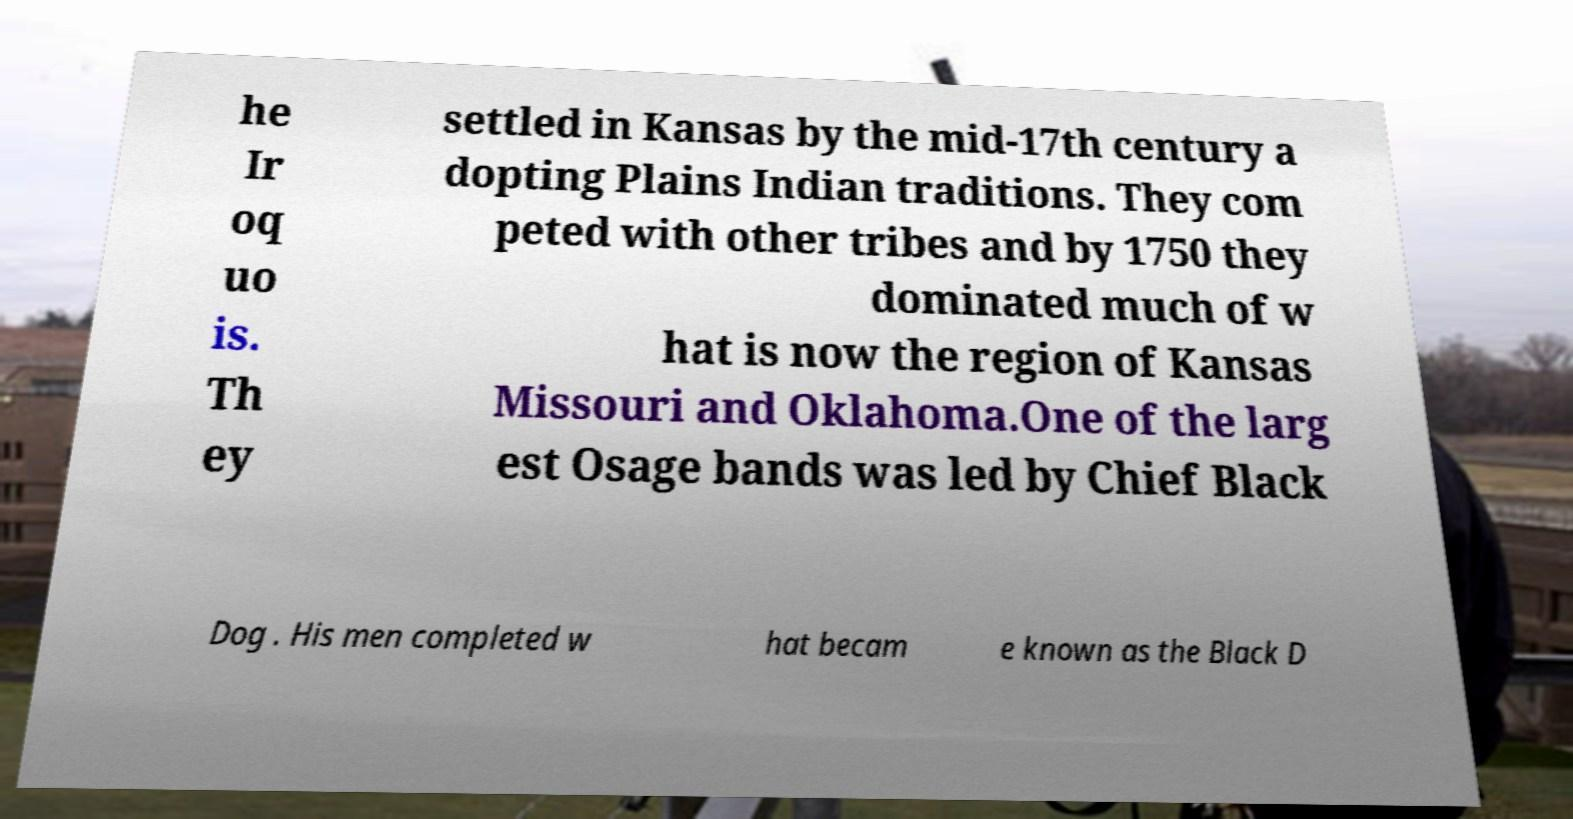What messages or text are displayed in this image? I need them in a readable, typed format. he Ir oq uo is. Th ey settled in Kansas by the mid-17th century a dopting Plains Indian traditions. They com peted with other tribes and by 1750 they dominated much of w hat is now the region of Kansas Missouri and Oklahoma.One of the larg est Osage bands was led by Chief Black Dog . His men completed w hat becam e known as the Black D 